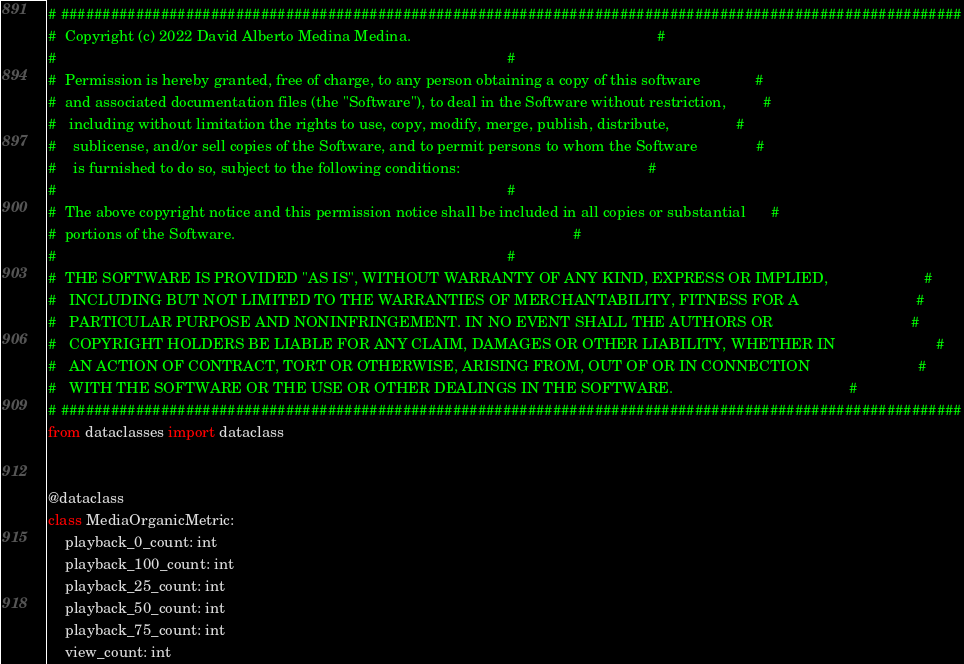<code> <loc_0><loc_0><loc_500><loc_500><_Python_># ############################################################################################################
#  Copyright (c) 2022 David Alberto Medina Medina.                                                           #
#                                                                                                            #
#  Permission is hereby granted, free of charge, to any person obtaining a copy of this software             #
#  and associated documentation files (the "Software"), to deal in the Software without restriction,         #
#   including without limitation the rights to use, copy, modify, merge, publish, distribute,                #
#    sublicense, and/or sell copies of the Software, and to permit persons to whom the Software              #
#    is furnished to do so, subject to the following conditions:                                             #
#                                                                                                            #
#  The above copyright notice and this permission notice shall be included in all copies or substantial      #
#  portions of the Software.                                                                                 #
#                                                                                                            #
#  THE SOFTWARE IS PROVIDED "AS IS", WITHOUT WARRANTY OF ANY KIND, EXPRESS OR IMPLIED,                       #
#   INCLUDING BUT NOT LIMITED TO THE WARRANTIES OF MERCHANTABILITY, FITNESS FOR A                            #
#   PARTICULAR PURPOSE AND NONINFRINGEMENT. IN NO EVENT SHALL THE AUTHORS OR                                 #
#   COPYRIGHT HOLDERS BE LIABLE FOR ANY CLAIM, DAMAGES OR OTHER LIABILITY, WHETHER IN                        #
#   AN ACTION OF CONTRACT, TORT OR OTHERWISE, ARISING FROM, OUT OF OR IN CONNECTION                          #
#   WITH THE SOFTWARE OR THE USE OR OTHER DEALINGS IN THE SOFTWARE.                                          #
# ############################################################################################################
from dataclasses import dataclass


@dataclass
class MediaOrganicMetric:
    playback_0_count: int
    playback_100_count: int
    playback_25_count: int
    playback_50_count: int
    playback_75_count: int
    view_count: int
</code> 